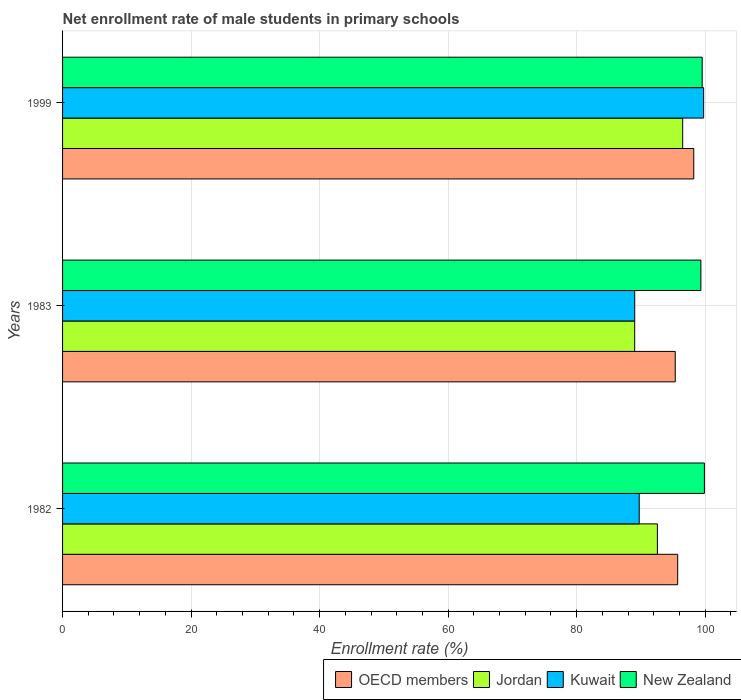How many different coloured bars are there?
Offer a very short reply. 4. Are the number of bars per tick equal to the number of legend labels?
Give a very brief answer. Yes. How many bars are there on the 3rd tick from the top?
Your answer should be very brief. 4. How many bars are there on the 1st tick from the bottom?
Ensure brevity in your answer.  4. What is the net enrollment rate of male students in primary schools in New Zealand in 1983?
Offer a terse response. 99.32. Across all years, what is the maximum net enrollment rate of male students in primary schools in Kuwait?
Your answer should be compact. 99.75. Across all years, what is the minimum net enrollment rate of male students in primary schools in Jordan?
Make the answer very short. 89.03. In which year was the net enrollment rate of male students in primary schools in Kuwait maximum?
Offer a very short reply. 1999. In which year was the net enrollment rate of male students in primary schools in OECD members minimum?
Make the answer very short. 1983. What is the total net enrollment rate of male students in primary schools in New Zealand in the graph?
Give a very brief answer. 298.73. What is the difference between the net enrollment rate of male students in primary schools in New Zealand in 1982 and that in 1983?
Your answer should be very brief. 0.55. What is the difference between the net enrollment rate of male students in primary schools in New Zealand in 1983 and the net enrollment rate of male students in primary schools in Kuwait in 1999?
Offer a very short reply. -0.43. What is the average net enrollment rate of male students in primary schools in New Zealand per year?
Give a very brief answer. 99.58. In the year 1999, what is the difference between the net enrollment rate of male students in primary schools in Kuwait and net enrollment rate of male students in primary schools in Jordan?
Ensure brevity in your answer.  3.26. In how many years, is the net enrollment rate of male students in primary schools in New Zealand greater than 36 %?
Offer a very short reply. 3. What is the ratio of the net enrollment rate of male students in primary schools in New Zealand in 1982 to that in 1983?
Your answer should be very brief. 1.01. Is the net enrollment rate of male students in primary schools in Jordan in 1982 less than that in 1999?
Provide a succinct answer. Yes. What is the difference between the highest and the second highest net enrollment rate of male students in primary schools in New Zealand?
Keep it short and to the point. 0.34. What is the difference between the highest and the lowest net enrollment rate of male students in primary schools in Jordan?
Offer a terse response. 7.47. Is the sum of the net enrollment rate of male students in primary schools in New Zealand in 1982 and 1983 greater than the maximum net enrollment rate of male students in primary schools in Jordan across all years?
Your response must be concise. Yes. Is it the case that in every year, the sum of the net enrollment rate of male students in primary schools in OECD members and net enrollment rate of male students in primary schools in Kuwait is greater than the sum of net enrollment rate of male students in primary schools in New Zealand and net enrollment rate of male students in primary schools in Jordan?
Your answer should be very brief. No. What does the 2nd bar from the top in 1983 represents?
Provide a succinct answer. Kuwait. What does the 3rd bar from the bottom in 1982 represents?
Ensure brevity in your answer.  Kuwait. How many bars are there?
Offer a terse response. 12. Are all the bars in the graph horizontal?
Your response must be concise. Yes. Are the values on the major ticks of X-axis written in scientific E-notation?
Keep it short and to the point. No. Does the graph contain grids?
Keep it short and to the point. Yes. Where does the legend appear in the graph?
Give a very brief answer. Bottom right. What is the title of the graph?
Provide a succinct answer. Net enrollment rate of male students in primary schools. Does "Sudan" appear as one of the legend labels in the graph?
Ensure brevity in your answer.  No. What is the label or title of the X-axis?
Provide a short and direct response. Enrollment rate (%). What is the Enrollment rate (%) in OECD members in 1982?
Your response must be concise. 95.72. What is the Enrollment rate (%) of Jordan in 1982?
Keep it short and to the point. 92.56. What is the Enrollment rate (%) in Kuwait in 1982?
Offer a very short reply. 89.73. What is the Enrollment rate (%) in New Zealand in 1982?
Offer a very short reply. 99.87. What is the Enrollment rate (%) in OECD members in 1983?
Make the answer very short. 95.34. What is the Enrollment rate (%) in Jordan in 1983?
Your answer should be very brief. 89.03. What is the Enrollment rate (%) in Kuwait in 1983?
Keep it short and to the point. 89.03. What is the Enrollment rate (%) in New Zealand in 1983?
Ensure brevity in your answer.  99.32. What is the Enrollment rate (%) of OECD members in 1999?
Keep it short and to the point. 98.22. What is the Enrollment rate (%) of Jordan in 1999?
Provide a succinct answer. 96.49. What is the Enrollment rate (%) in Kuwait in 1999?
Offer a very short reply. 99.75. What is the Enrollment rate (%) in New Zealand in 1999?
Make the answer very short. 99.53. Across all years, what is the maximum Enrollment rate (%) in OECD members?
Ensure brevity in your answer.  98.22. Across all years, what is the maximum Enrollment rate (%) in Jordan?
Your answer should be compact. 96.49. Across all years, what is the maximum Enrollment rate (%) in Kuwait?
Your answer should be very brief. 99.75. Across all years, what is the maximum Enrollment rate (%) in New Zealand?
Provide a succinct answer. 99.87. Across all years, what is the minimum Enrollment rate (%) of OECD members?
Keep it short and to the point. 95.34. Across all years, what is the minimum Enrollment rate (%) of Jordan?
Give a very brief answer. 89.03. Across all years, what is the minimum Enrollment rate (%) of Kuwait?
Make the answer very short. 89.03. Across all years, what is the minimum Enrollment rate (%) of New Zealand?
Your answer should be compact. 99.32. What is the total Enrollment rate (%) of OECD members in the graph?
Ensure brevity in your answer.  289.27. What is the total Enrollment rate (%) of Jordan in the graph?
Ensure brevity in your answer.  278.08. What is the total Enrollment rate (%) of Kuwait in the graph?
Offer a very short reply. 278.51. What is the total Enrollment rate (%) of New Zealand in the graph?
Your answer should be very brief. 298.73. What is the difference between the Enrollment rate (%) of OECD members in 1982 and that in 1983?
Provide a succinct answer. 0.38. What is the difference between the Enrollment rate (%) of Jordan in 1982 and that in 1983?
Provide a short and direct response. 3.53. What is the difference between the Enrollment rate (%) of Kuwait in 1982 and that in 1983?
Offer a very short reply. 0.7. What is the difference between the Enrollment rate (%) in New Zealand in 1982 and that in 1983?
Your response must be concise. 0.55. What is the difference between the Enrollment rate (%) of OECD members in 1982 and that in 1999?
Offer a very short reply. -2.5. What is the difference between the Enrollment rate (%) in Jordan in 1982 and that in 1999?
Offer a terse response. -3.94. What is the difference between the Enrollment rate (%) in Kuwait in 1982 and that in 1999?
Ensure brevity in your answer.  -10.02. What is the difference between the Enrollment rate (%) in New Zealand in 1982 and that in 1999?
Ensure brevity in your answer.  0.34. What is the difference between the Enrollment rate (%) of OECD members in 1983 and that in 1999?
Make the answer very short. -2.88. What is the difference between the Enrollment rate (%) in Jordan in 1983 and that in 1999?
Provide a short and direct response. -7.47. What is the difference between the Enrollment rate (%) in Kuwait in 1983 and that in 1999?
Offer a terse response. -10.72. What is the difference between the Enrollment rate (%) in New Zealand in 1983 and that in 1999?
Offer a terse response. -0.2. What is the difference between the Enrollment rate (%) in OECD members in 1982 and the Enrollment rate (%) in Jordan in 1983?
Offer a terse response. 6.69. What is the difference between the Enrollment rate (%) of OECD members in 1982 and the Enrollment rate (%) of Kuwait in 1983?
Keep it short and to the point. 6.69. What is the difference between the Enrollment rate (%) of OECD members in 1982 and the Enrollment rate (%) of New Zealand in 1983?
Ensure brevity in your answer.  -3.61. What is the difference between the Enrollment rate (%) in Jordan in 1982 and the Enrollment rate (%) in Kuwait in 1983?
Ensure brevity in your answer.  3.53. What is the difference between the Enrollment rate (%) of Jordan in 1982 and the Enrollment rate (%) of New Zealand in 1983?
Give a very brief answer. -6.77. What is the difference between the Enrollment rate (%) of Kuwait in 1982 and the Enrollment rate (%) of New Zealand in 1983?
Offer a terse response. -9.59. What is the difference between the Enrollment rate (%) of OECD members in 1982 and the Enrollment rate (%) of Jordan in 1999?
Your answer should be compact. -0.78. What is the difference between the Enrollment rate (%) of OECD members in 1982 and the Enrollment rate (%) of Kuwait in 1999?
Your answer should be compact. -4.04. What is the difference between the Enrollment rate (%) in OECD members in 1982 and the Enrollment rate (%) in New Zealand in 1999?
Offer a very short reply. -3.81. What is the difference between the Enrollment rate (%) of Jordan in 1982 and the Enrollment rate (%) of Kuwait in 1999?
Give a very brief answer. -7.19. What is the difference between the Enrollment rate (%) in Jordan in 1982 and the Enrollment rate (%) in New Zealand in 1999?
Ensure brevity in your answer.  -6.97. What is the difference between the Enrollment rate (%) of Kuwait in 1982 and the Enrollment rate (%) of New Zealand in 1999?
Your answer should be compact. -9.8. What is the difference between the Enrollment rate (%) in OECD members in 1983 and the Enrollment rate (%) in Jordan in 1999?
Offer a terse response. -1.16. What is the difference between the Enrollment rate (%) in OECD members in 1983 and the Enrollment rate (%) in Kuwait in 1999?
Your answer should be compact. -4.42. What is the difference between the Enrollment rate (%) in OECD members in 1983 and the Enrollment rate (%) in New Zealand in 1999?
Keep it short and to the point. -4.19. What is the difference between the Enrollment rate (%) in Jordan in 1983 and the Enrollment rate (%) in Kuwait in 1999?
Your answer should be compact. -10.73. What is the difference between the Enrollment rate (%) of Jordan in 1983 and the Enrollment rate (%) of New Zealand in 1999?
Offer a terse response. -10.5. What is the difference between the Enrollment rate (%) in Kuwait in 1983 and the Enrollment rate (%) in New Zealand in 1999?
Ensure brevity in your answer.  -10.5. What is the average Enrollment rate (%) of OECD members per year?
Give a very brief answer. 96.42. What is the average Enrollment rate (%) of Jordan per year?
Provide a succinct answer. 92.69. What is the average Enrollment rate (%) in Kuwait per year?
Keep it short and to the point. 92.84. What is the average Enrollment rate (%) in New Zealand per year?
Offer a terse response. 99.58. In the year 1982, what is the difference between the Enrollment rate (%) of OECD members and Enrollment rate (%) of Jordan?
Give a very brief answer. 3.16. In the year 1982, what is the difference between the Enrollment rate (%) in OECD members and Enrollment rate (%) in Kuwait?
Your answer should be very brief. 5.99. In the year 1982, what is the difference between the Enrollment rate (%) in OECD members and Enrollment rate (%) in New Zealand?
Ensure brevity in your answer.  -4.16. In the year 1982, what is the difference between the Enrollment rate (%) in Jordan and Enrollment rate (%) in Kuwait?
Make the answer very short. 2.83. In the year 1982, what is the difference between the Enrollment rate (%) in Jordan and Enrollment rate (%) in New Zealand?
Offer a very short reply. -7.31. In the year 1982, what is the difference between the Enrollment rate (%) in Kuwait and Enrollment rate (%) in New Zealand?
Ensure brevity in your answer.  -10.14. In the year 1983, what is the difference between the Enrollment rate (%) of OECD members and Enrollment rate (%) of Jordan?
Offer a very short reply. 6.31. In the year 1983, what is the difference between the Enrollment rate (%) in OECD members and Enrollment rate (%) in Kuwait?
Offer a terse response. 6.31. In the year 1983, what is the difference between the Enrollment rate (%) of OECD members and Enrollment rate (%) of New Zealand?
Ensure brevity in your answer.  -3.99. In the year 1983, what is the difference between the Enrollment rate (%) in Jordan and Enrollment rate (%) in Kuwait?
Your response must be concise. -0. In the year 1983, what is the difference between the Enrollment rate (%) in Jordan and Enrollment rate (%) in New Zealand?
Keep it short and to the point. -10.3. In the year 1983, what is the difference between the Enrollment rate (%) in Kuwait and Enrollment rate (%) in New Zealand?
Ensure brevity in your answer.  -10.29. In the year 1999, what is the difference between the Enrollment rate (%) of OECD members and Enrollment rate (%) of Jordan?
Keep it short and to the point. 1.72. In the year 1999, what is the difference between the Enrollment rate (%) in OECD members and Enrollment rate (%) in Kuwait?
Your response must be concise. -1.54. In the year 1999, what is the difference between the Enrollment rate (%) of OECD members and Enrollment rate (%) of New Zealand?
Offer a very short reply. -1.31. In the year 1999, what is the difference between the Enrollment rate (%) in Jordan and Enrollment rate (%) in Kuwait?
Ensure brevity in your answer.  -3.26. In the year 1999, what is the difference between the Enrollment rate (%) of Jordan and Enrollment rate (%) of New Zealand?
Your response must be concise. -3.03. In the year 1999, what is the difference between the Enrollment rate (%) of Kuwait and Enrollment rate (%) of New Zealand?
Your response must be concise. 0.22. What is the ratio of the Enrollment rate (%) of OECD members in 1982 to that in 1983?
Provide a succinct answer. 1. What is the ratio of the Enrollment rate (%) of Jordan in 1982 to that in 1983?
Keep it short and to the point. 1.04. What is the ratio of the Enrollment rate (%) of Kuwait in 1982 to that in 1983?
Your answer should be very brief. 1.01. What is the ratio of the Enrollment rate (%) in New Zealand in 1982 to that in 1983?
Your answer should be very brief. 1.01. What is the ratio of the Enrollment rate (%) of OECD members in 1982 to that in 1999?
Offer a very short reply. 0.97. What is the ratio of the Enrollment rate (%) in Jordan in 1982 to that in 1999?
Provide a short and direct response. 0.96. What is the ratio of the Enrollment rate (%) of Kuwait in 1982 to that in 1999?
Provide a succinct answer. 0.9. What is the ratio of the Enrollment rate (%) of OECD members in 1983 to that in 1999?
Offer a very short reply. 0.97. What is the ratio of the Enrollment rate (%) of Jordan in 1983 to that in 1999?
Your answer should be very brief. 0.92. What is the ratio of the Enrollment rate (%) of Kuwait in 1983 to that in 1999?
Keep it short and to the point. 0.89. What is the ratio of the Enrollment rate (%) of New Zealand in 1983 to that in 1999?
Make the answer very short. 1. What is the difference between the highest and the second highest Enrollment rate (%) in OECD members?
Ensure brevity in your answer.  2.5. What is the difference between the highest and the second highest Enrollment rate (%) of Jordan?
Offer a terse response. 3.94. What is the difference between the highest and the second highest Enrollment rate (%) of Kuwait?
Your answer should be compact. 10.02. What is the difference between the highest and the second highest Enrollment rate (%) in New Zealand?
Ensure brevity in your answer.  0.34. What is the difference between the highest and the lowest Enrollment rate (%) of OECD members?
Make the answer very short. 2.88. What is the difference between the highest and the lowest Enrollment rate (%) of Jordan?
Your response must be concise. 7.47. What is the difference between the highest and the lowest Enrollment rate (%) in Kuwait?
Offer a terse response. 10.72. What is the difference between the highest and the lowest Enrollment rate (%) in New Zealand?
Offer a terse response. 0.55. 